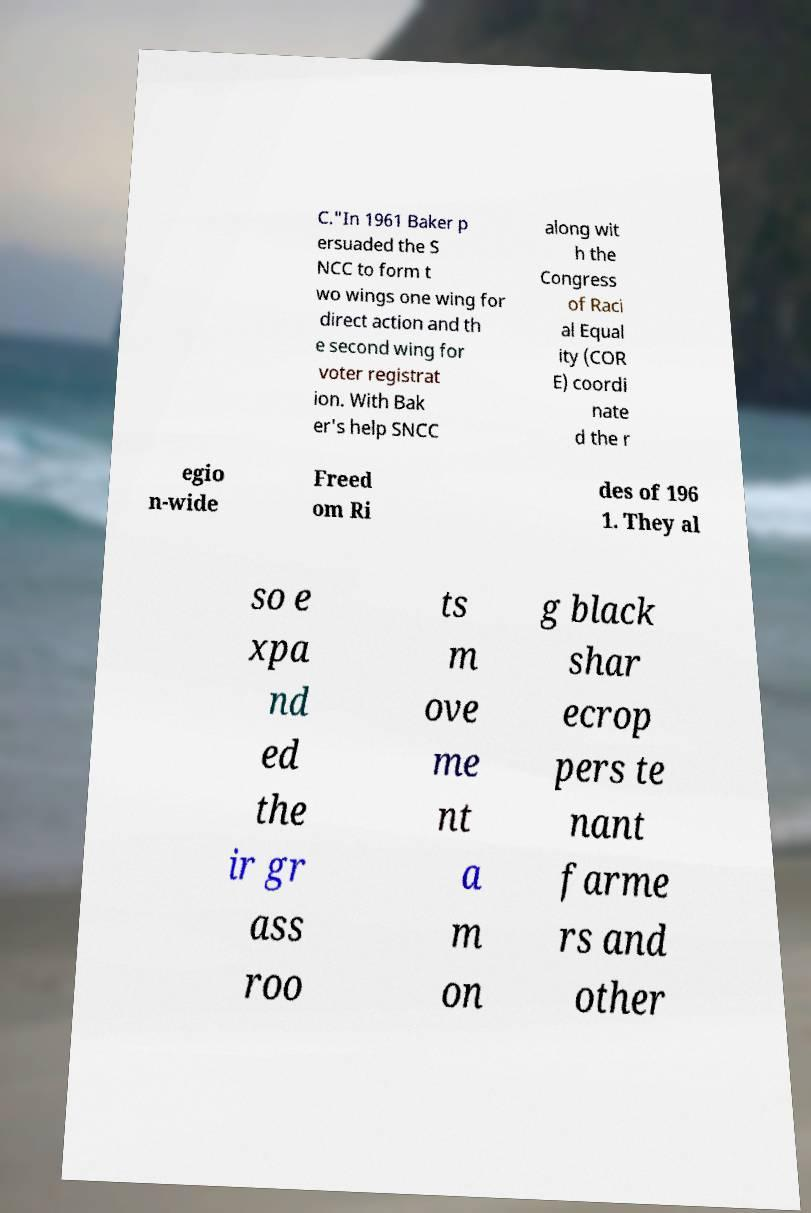Please identify and transcribe the text found in this image. C."In 1961 Baker p ersuaded the S NCC to form t wo wings one wing for direct action and th e second wing for voter registrat ion. With Bak er's help SNCC along wit h the Congress of Raci al Equal ity (COR E) coordi nate d the r egio n-wide Freed om Ri des of 196 1. They al so e xpa nd ed the ir gr ass roo ts m ove me nt a m on g black shar ecrop pers te nant farme rs and other 